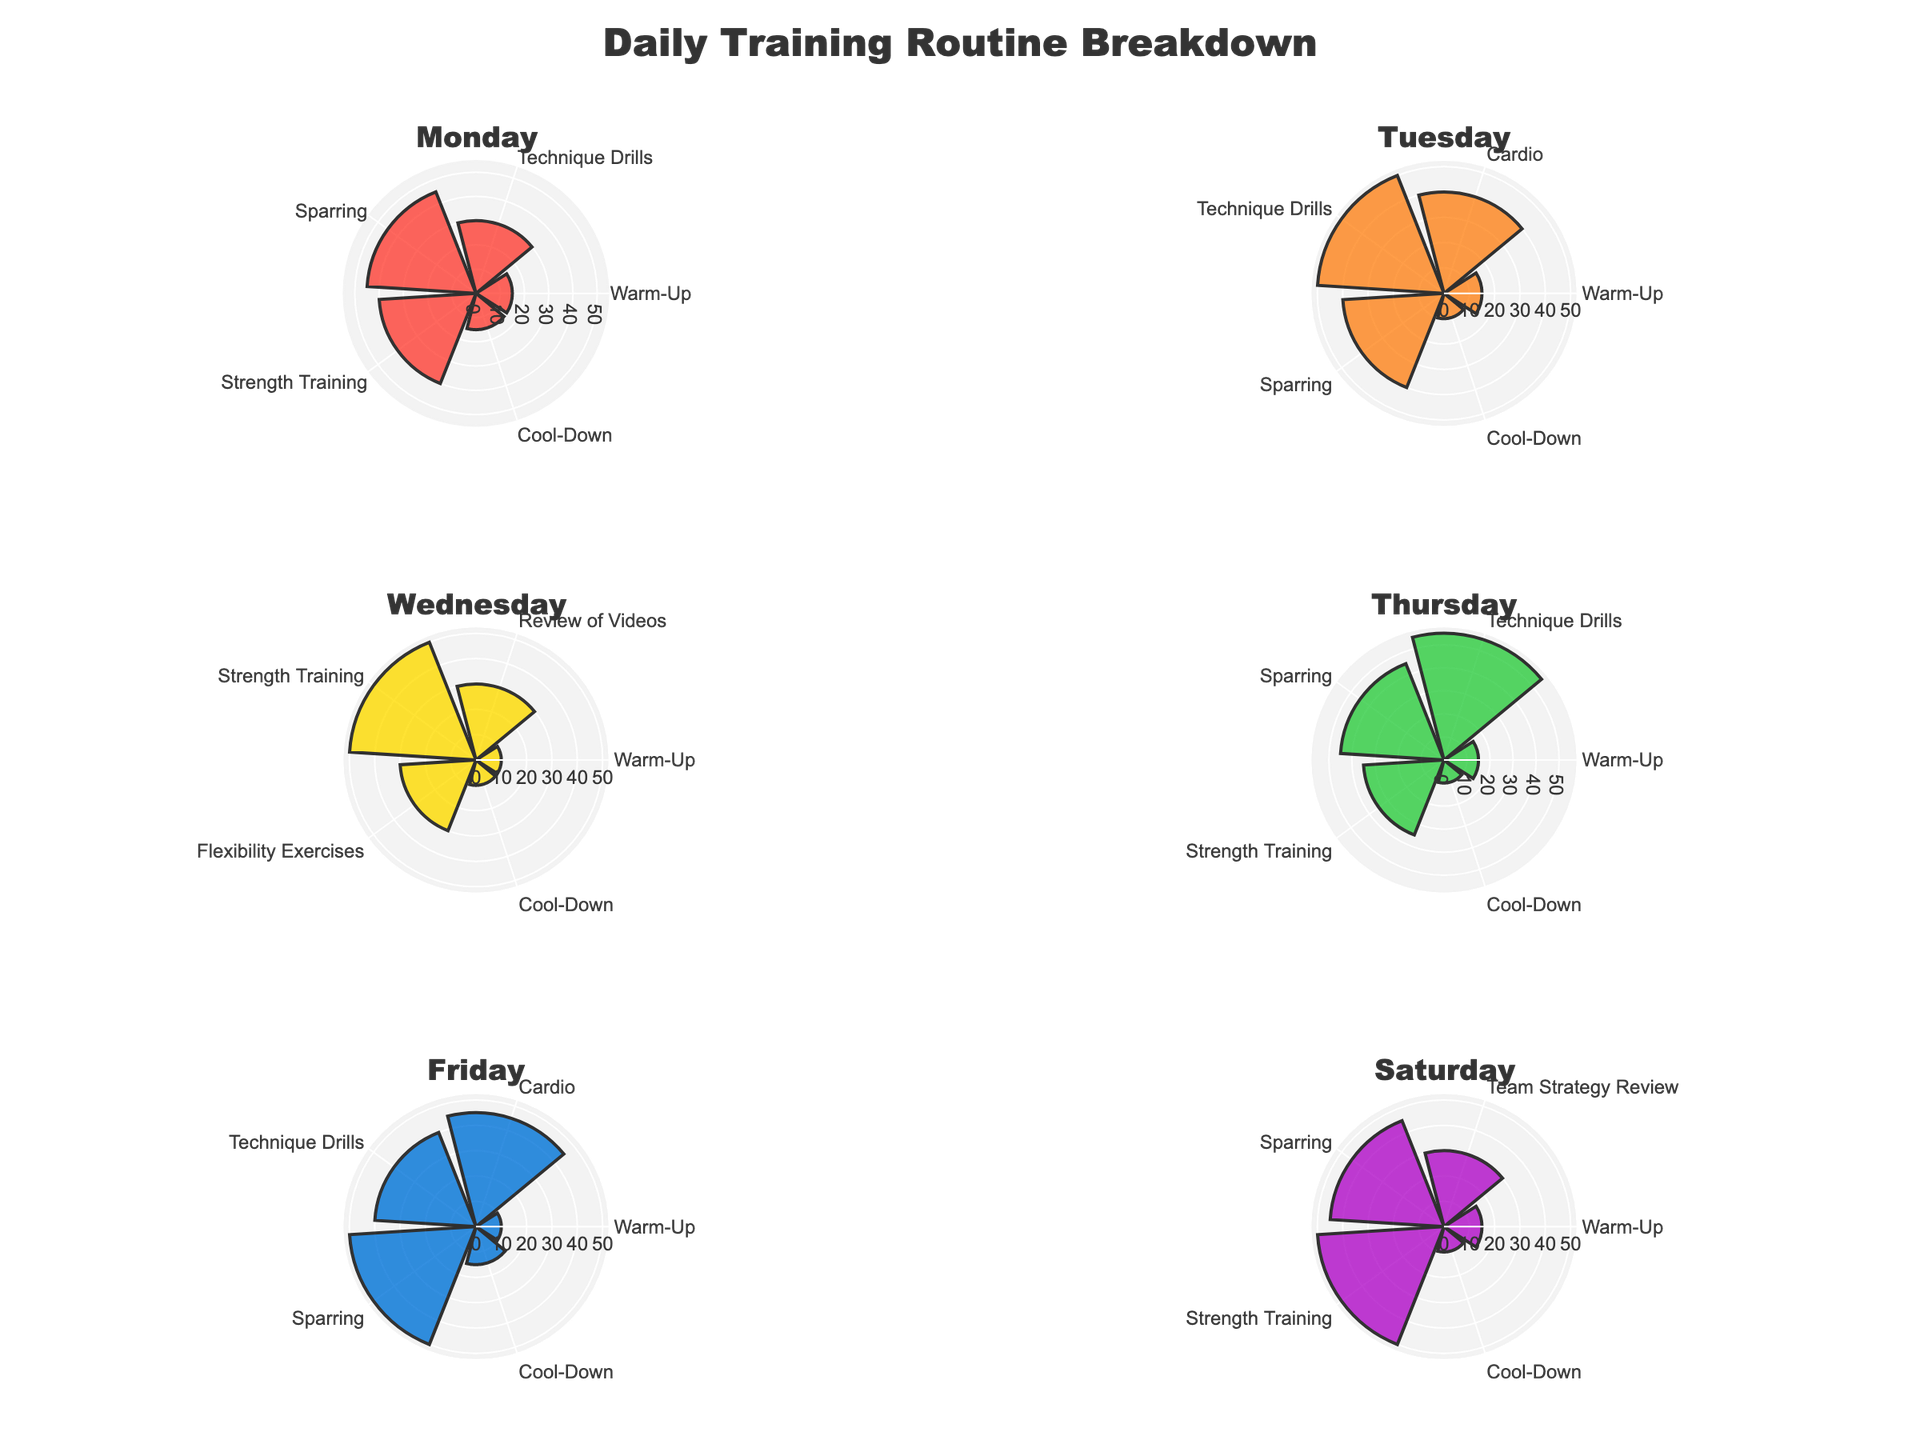What is the title of the entire figure? The title is displayed prominently at the top of the figure and reads "Daily Training Routine Breakdown."
Answer: Daily Training Routine Breakdown Which day has the longest single exercise duration? By looking at the lengths of the bars extending outward from each day's subplot, Friday has the longest single exercise duration of 50 minutes for Sparring.
Answer: Friday On which day is "Technique Drills" the longest, and how long is it? By comparing the lengths of the "Technique Drills" bars across all days' subplots, Thursday's "Technique Drills" is the longest at 55 minutes.
Answer: Thursday, 55 minutes How does the duration of "Warm-Up" on Monday compare to that on Wednesday? On Monday, the "Warm-Up" duration is 15 minutes, whereas on Wednesday it is 10 minutes.
Answer: 15 minutes on Monday, 10 minutes on Wednesday What is the total duration of "Sparring" over the entire week? Adding up the durations of "Sparring" for each day: 45 (Monday) + 40 (Tuesday) + 45 (Thursday) + 50 (Friday) + 45 (Saturday) = 225 minutes.
Answer: 225 minutes Which day has the most variety in exercise types? Counting the different exercise types in each day's subplot, Thursday has the most with five distinct types.
Answer: Thursday Does "Cool-Down" have a consistent duration throughout the week? Checking each day's subplot, "Cool-Down" lasts 15 minutes on Monday and Friday, and 10 minutes on other days, hence it is not consistent.
Answer: No Which day has the shortest overall training time, and how can you tell? Comparing the total length of all bars in each day's subplot suggests that Wednesday has the shortest overall training duration.
Answer: Wednesday On which day did "Cardio" have the longest duration, and how long was it? By examining the "Cardio" bars, Friday's "Cardio" has the longest duration of 45 minutes.
Answer: Friday, 45 minutes What is the average duration of "Strength Training" across the days it appears? "Strength Training" appears on Monday (40 minutes), Wednesday (50 minutes), Thursday (35 minutes), and Saturday (50 minutes). (40+50+35+50)/4 = 175/4 = 43.75 minutes.
Answer: 43.75 minutes 